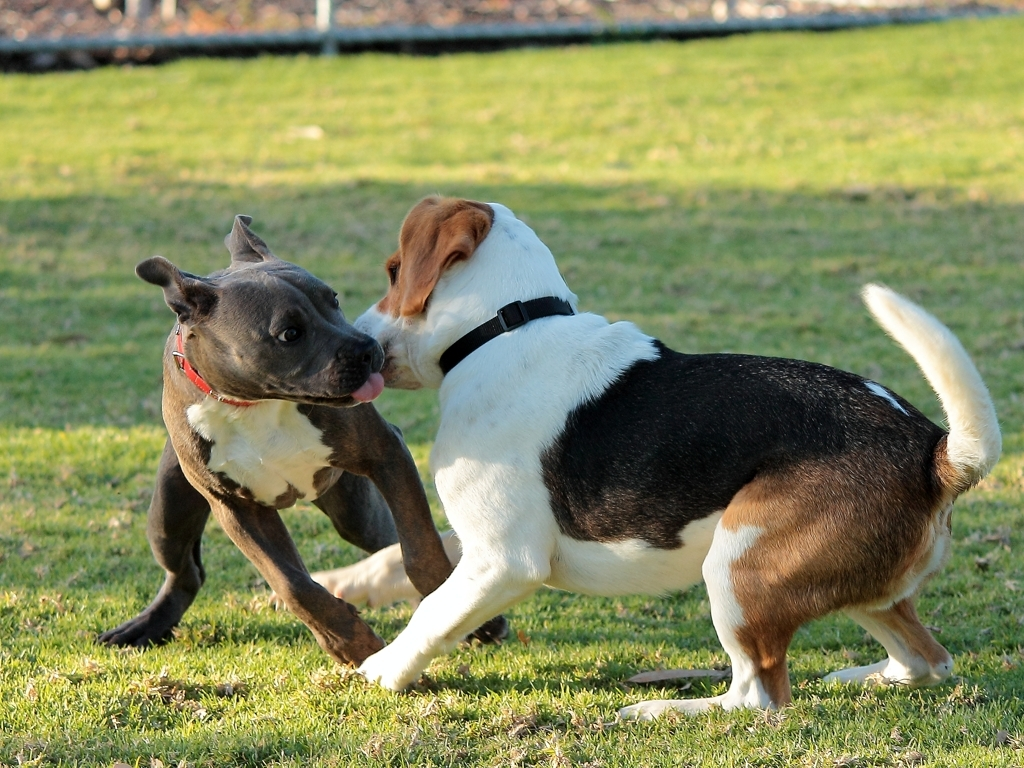Can you describe the behavior of the dogs in the picture? Certainly! The dogs display a classic example of playful interaction, which includes light nipping or mock biting and energetic stances. Such behavior is common in canines and signifies a friendly, social play rather than aggression. Their open mouths and forward-leaning postures indicate they are thoroughly enjoying their playtime. 